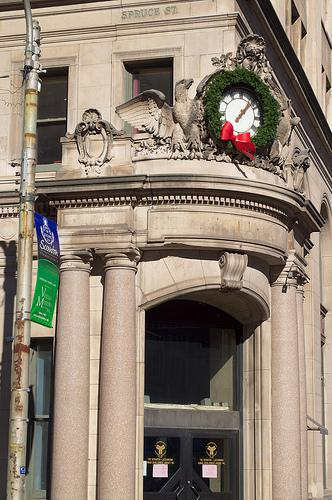Question: what does it say on the building?
Choices:
A. Spruce st.
B. Green st.
C. Oak st.
D. Maple st.
Answer with the letter. Answer: A Question: who is taking the picture?
Choices:
A. A regular man.
B. A regular woman.
C. A photographer.
D. A child.
Answer with the letter. Answer: C Question: what time of day is it?
Choices:
A. Night time.
B. Dawn.
C. Day time.
D. Dusk.
Answer with the letter. Answer: C Question: what color is the ribbon on the clock?
Choices:
A. Teal.
B. Purple.
C. Neon.
D. Red.
Answer with the letter. Answer: D Question: where was the picture taken?
Choices:
A. Zoo.
B. Casino.
C. Park.
D. Outside building.
Answer with the letter. Answer: D 